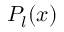<formula> <loc_0><loc_0><loc_500><loc_500>P _ { l } ( x )</formula> 